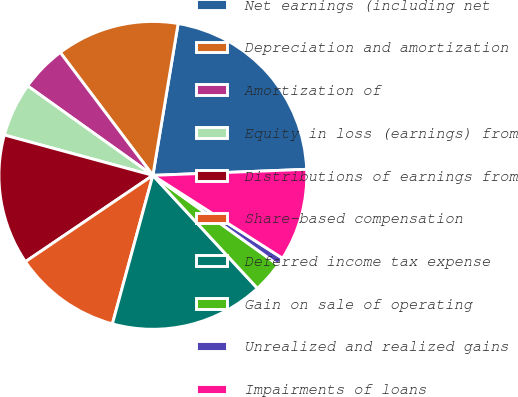Convert chart. <chart><loc_0><loc_0><loc_500><loc_500><pie_chart><fcel>Net earnings (including net<fcel>Depreciation and amortization<fcel>Amortization of<fcel>Equity in loss (earnings) from<fcel>Distributions of earnings from<fcel>Share-based compensation<fcel>Deferred income tax expense<fcel>Gain on sale of operating<fcel>Unrealized and realized gains<fcel>Impairments of loans<nl><fcel>21.75%<fcel>12.9%<fcel>4.85%<fcel>5.65%<fcel>13.7%<fcel>11.29%<fcel>16.12%<fcel>3.24%<fcel>0.82%<fcel>9.68%<nl></chart> 